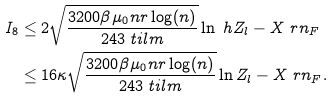<formula> <loc_0><loc_0><loc_500><loc_500>I _ { 8 } & \leq 2 \sqrt { \frac { 3 2 0 0 \beta \mu _ { 0 } n r \log ( n ) } { 2 4 3 \ t i l m } } \ln \ h Z _ { l } - X \ r n _ { F } \\ & \leq 1 6 \kappa \sqrt { \frac { 3 2 0 0 \beta \mu _ { 0 } n r \log ( n ) } { 2 4 3 \ t i l m } } \ln Z _ { l } - X \ r n _ { F } .</formula> 